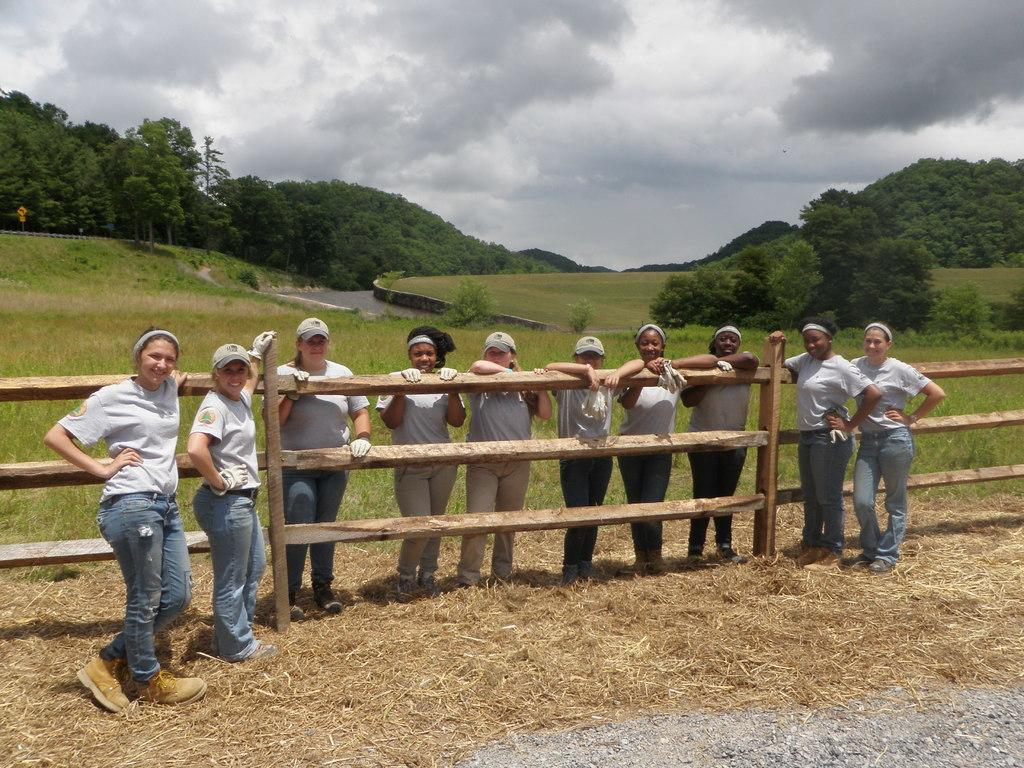Who or what can be seen in the image? There are people in the image. What can be seen near the people? There are railings in the image. What type of natural environment is visible in the image? There is grass, water, trees, and plants in the image. What other objects can be seen in the image? There are boards in the image. How would you describe the weather in the image? The sky is cloudy in the image. What type of pizzas can be seen in the image? There are no pizzas present in the image. Is there a cactus visible in the image? There is no cactus present in the image. 